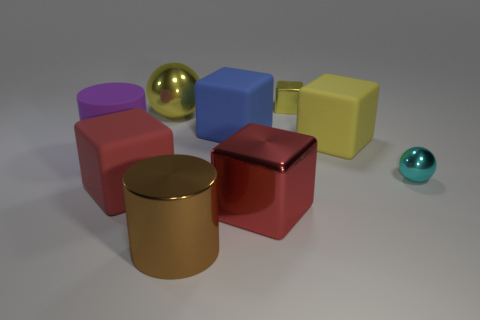What is the arrangement of objects in the image, and what can it signify? The objects are arranged seemingly at random, with varying distances between them. This arrangement might signify the arbitrary nature of the objects' placement, each item standing independently yet part of a collective ensemble, perhaps to showcase diversity in form and color. 